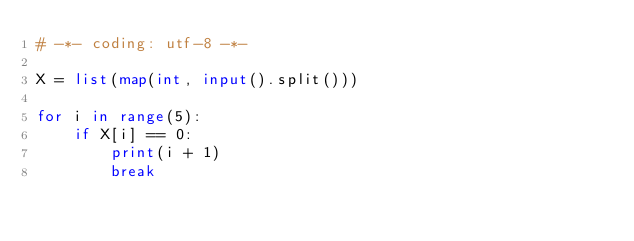<code> <loc_0><loc_0><loc_500><loc_500><_Python_># -*- coding: utf-8 -*-

X = list(map(int, input().split()))

for i in range(5):
    if X[i] == 0:
        print(i + 1)
        break
</code> 